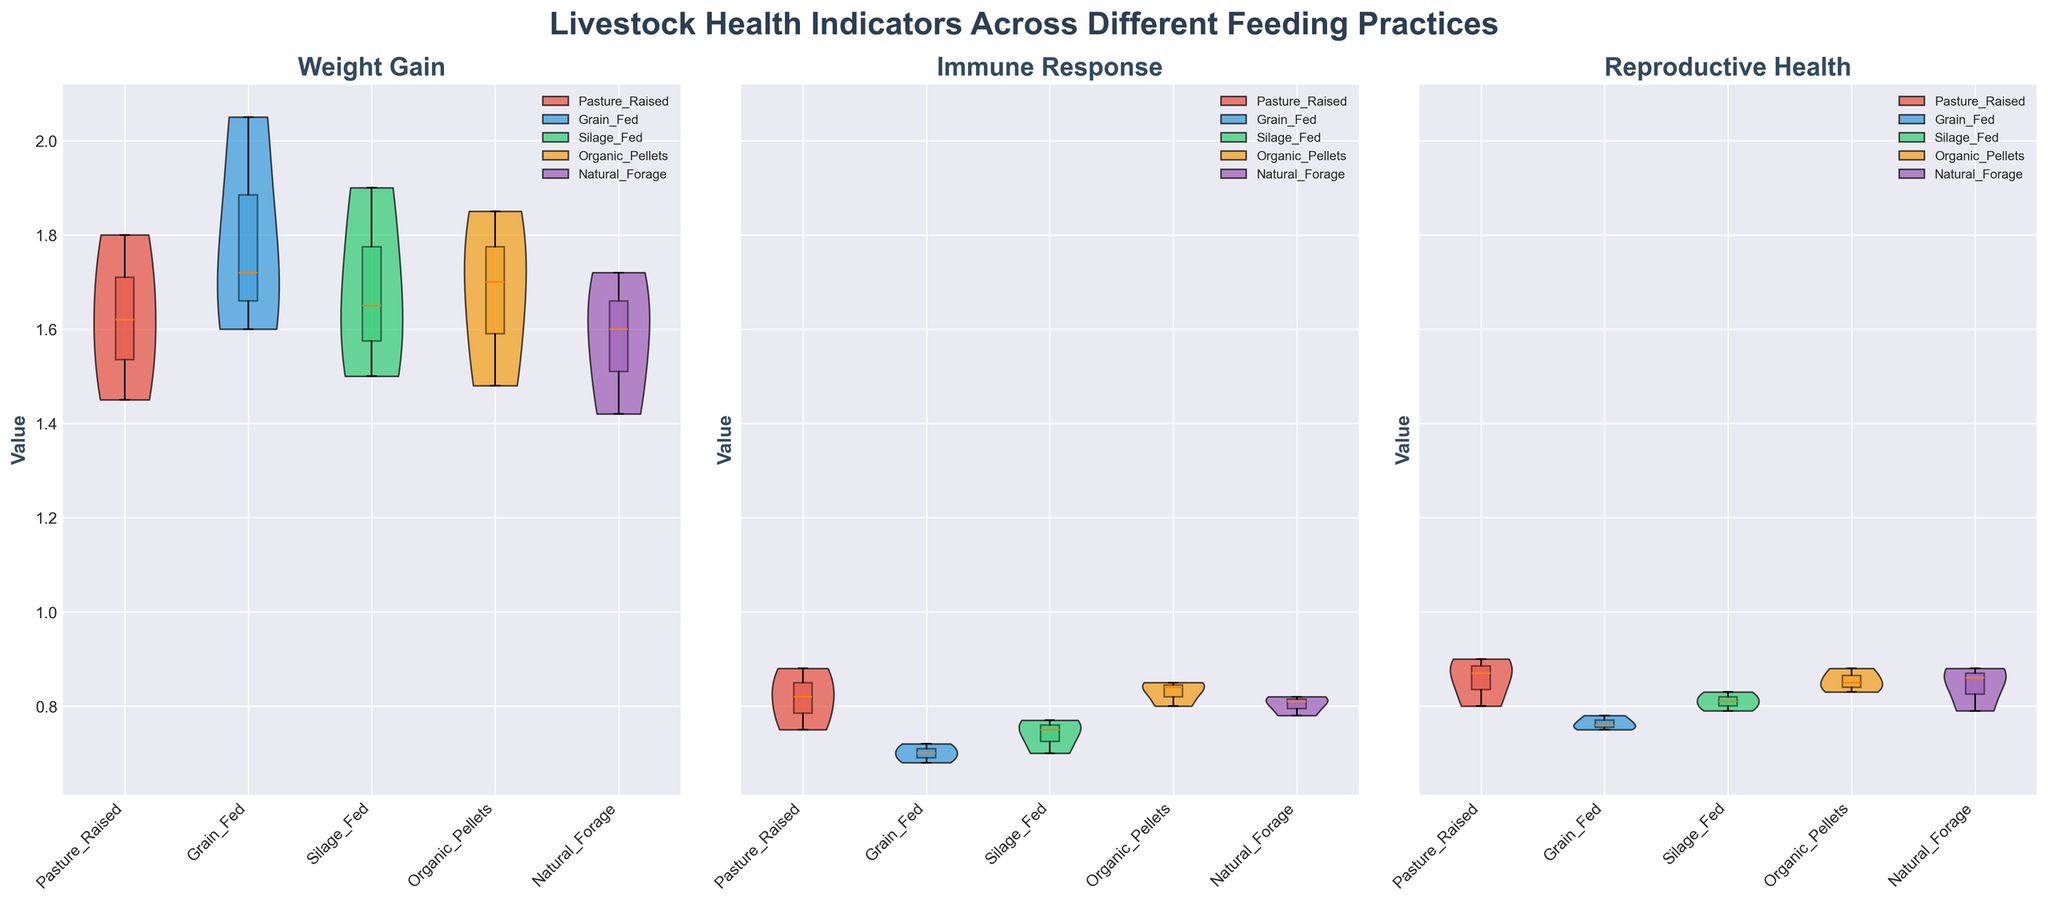Which feeding practice shows the highest median weight gain for livestock? To find the highest median weight gain, observe the horizontal line in the box plot overlay that represents the median value. Compare these medians across all feeding practices.
Answer: Grain_Fed Which livestock type under the organic pellets feeding practice has the highest immune response? Look at the Box Plot section under "Immune Response" for "Organic_Pellets" and compare the highest values from the box plots for cattle, sheep, and pigs.
Answer: Sheep Which feeding practice has the lowest median reproductive health value? Identify the horizontal line inside the box plot overlay that represents the median value for each feeding practice in the "Reproductive Health" section. Select the one with the lowest position.
Answer: Grain_Fed How does the range of weight gain (from lowest to highest) for pasture-raised livestock compare to that of silage-fed livestock? Identify the range in the Box Plot by looking at the positions of the lowest and highest points on the violin and box plots. Compare these ranges between pasture-raised and silage-fed practices under "Weight Gain."
Answer: Pasture_Raised has a wider range What can you infer about the consistency of reproductive health values among different feeding practices? Observe the width of the box plots and the spread of the data in the violin plots across different feeding practices for "Reproductive Health." Consistency is indicated by tighter box and violin plots.
Answer: Organic_Pellets and Natural_Forage are more consistent Which feeding practice shows the most variable immune response across all livestock types? Check the span of the violin plot for "Immune Response" across all livestock types and identify which feeding practice has the widest spread.
Answer: Grain_Fed Do pasture-raised livestock show a higher median immune response than grain-fed livestock? Compare the median lines in the box plots for "Immune Response" between pasture-raised and grain-fed feeding practices.
Answer: Yes For pigs, compare the median weight gain across all feeding practices. Which practice shows the highest median? Observe the box plot medians for "Weight_Gain" specific to pigs across all feeding practices. Compare these medians and identify the highest one.
Answer: Grain_Fed Are immune responses generally higher for livestock under organic pellets than under silage feeding practice? Compare the median lines in the box plots for "Immune Response" under "Organic_Pellets" and "Silage_Fed."
Answer: Yes 